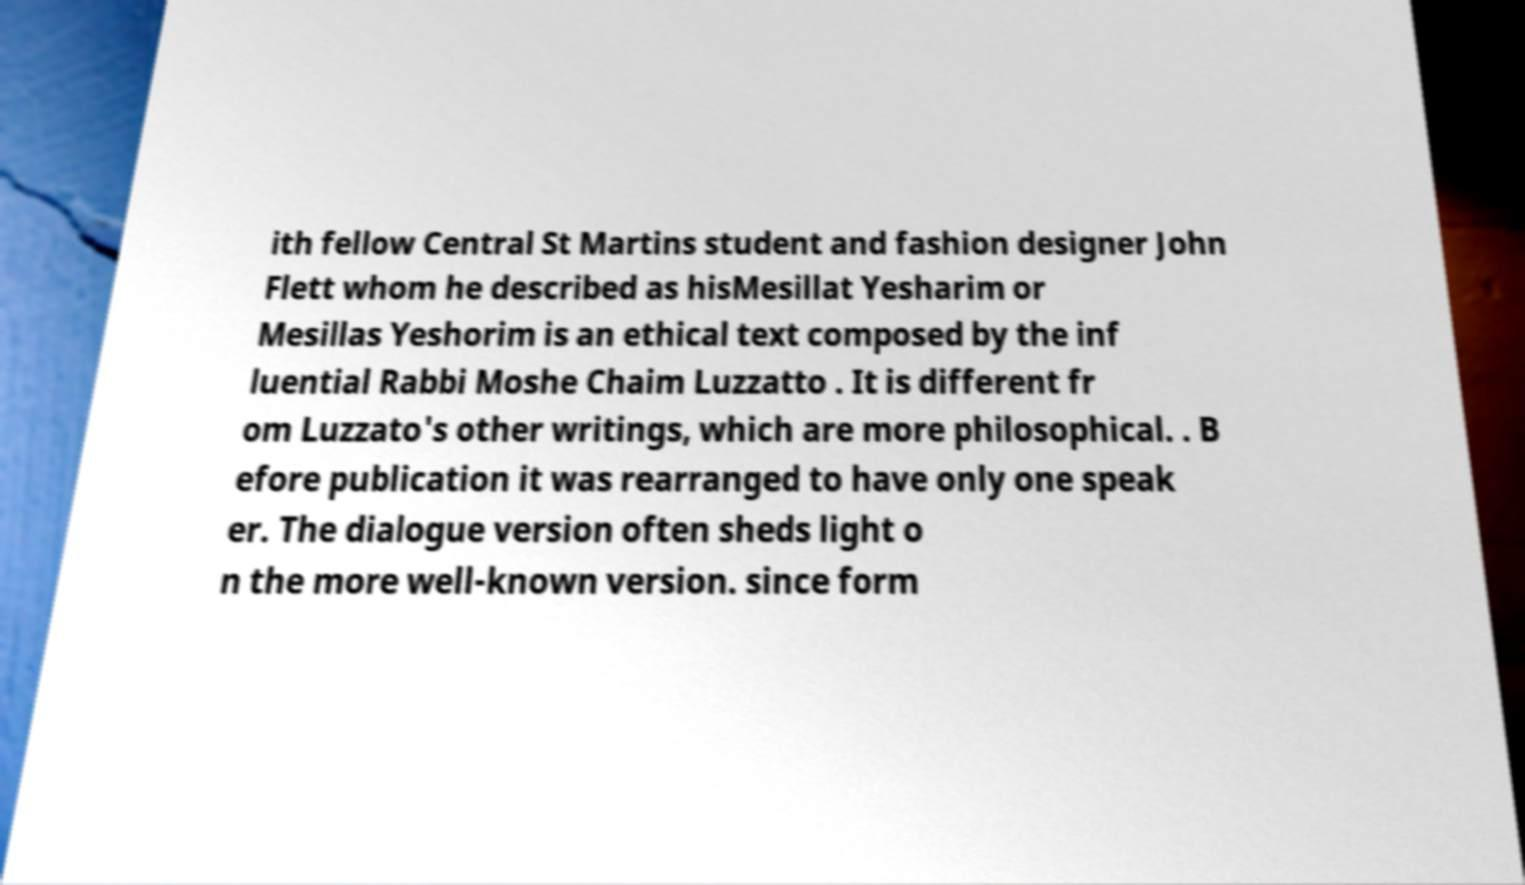What messages or text are displayed in this image? I need them in a readable, typed format. ith fellow Central St Martins student and fashion designer John Flett whom he described as hisMesillat Yesharim or Mesillas Yeshorim is an ethical text composed by the inf luential Rabbi Moshe Chaim Luzzatto . It is different fr om Luzzato's other writings, which are more philosophical. . B efore publication it was rearranged to have only one speak er. The dialogue version often sheds light o n the more well-known version. since form 